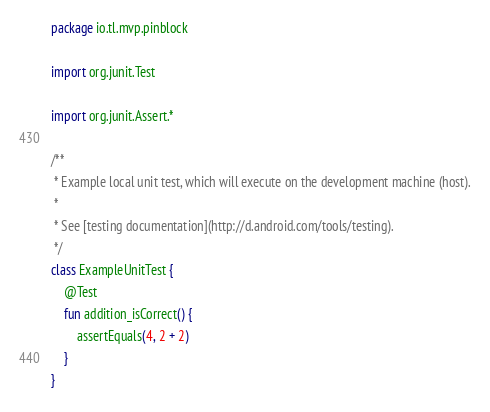Convert code to text. <code><loc_0><loc_0><loc_500><loc_500><_Kotlin_>package io.tl.mvp.pinblock

import org.junit.Test

import org.junit.Assert.*

/**
 * Example local unit test, which will execute on the development machine (host).
 *
 * See [testing documentation](http://d.android.com/tools/testing).
 */
class ExampleUnitTest {
    @Test
    fun addition_isCorrect() {
        assertEquals(4, 2 + 2)
    }
}</code> 